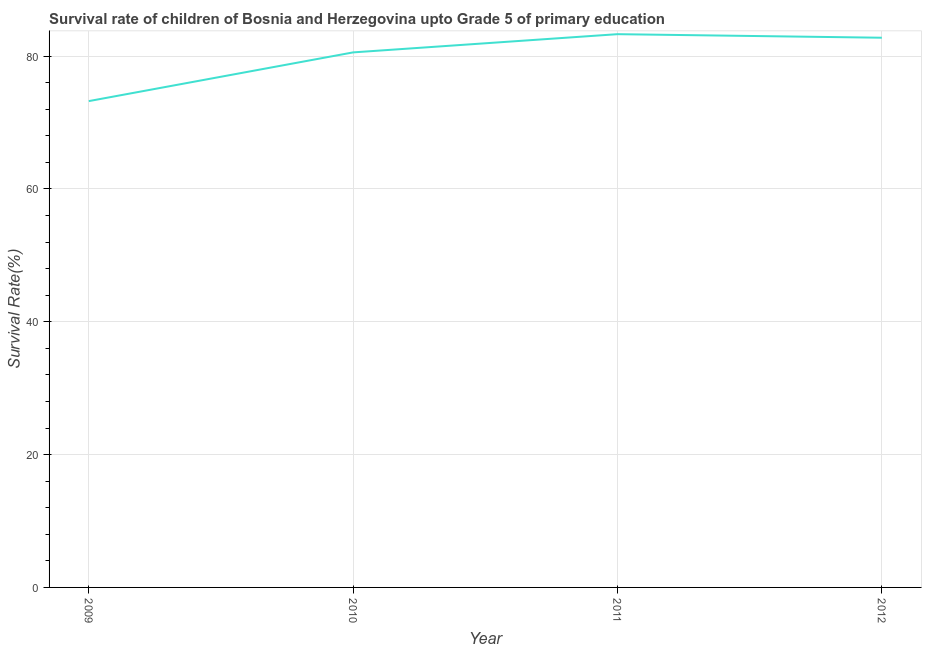What is the survival rate in 2010?
Your response must be concise. 80.56. Across all years, what is the maximum survival rate?
Provide a short and direct response. 83.31. Across all years, what is the minimum survival rate?
Offer a very short reply. 73.23. In which year was the survival rate maximum?
Your response must be concise. 2011. What is the sum of the survival rate?
Your answer should be compact. 319.87. What is the difference between the survival rate in 2011 and 2012?
Your answer should be compact. 0.54. What is the average survival rate per year?
Your answer should be compact. 79.97. What is the median survival rate?
Your response must be concise. 81.67. Do a majority of the years between 2010 and 2012 (inclusive) have survival rate greater than 8 %?
Make the answer very short. Yes. What is the ratio of the survival rate in 2009 to that in 2012?
Your answer should be compact. 0.88. Is the survival rate in 2010 less than that in 2012?
Your answer should be very brief. Yes. Is the difference between the survival rate in 2009 and 2010 greater than the difference between any two years?
Your answer should be compact. No. What is the difference between the highest and the second highest survival rate?
Provide a short and direct response. 0.54. What is the difference between the highest and the lowest survival rate?
Keep it short and to the point. 10.08. In how many years, is the survival rate greater than the average survival rate taken over all years?
Your answer should be compact. 3. How many lines are there?
Provide a short and direct response. 1. How many years are there in the graph?
Offer a very short reply. 4. What is the difference between two consecutive major ticks on the Y-axis?
Your response must be concise. 20. Are the values on the major ticks of Y-axis written in scientific E-notation?
Offer a very short reply. No. Does the graph contain any zero values?
Offer a terse response. No. What is the title of the graph?
Offer a terse response. Survival rate of children of Bosnia and Herzegovina upto Grade 5 of primary education. What is the label or title of the Y-axis?
Keep it short and to the point. Survival Rate(%). What is the Survival Rate(%) of 2009?
Provide a short and direct response. 73.23. What is the Survival Rate(%) of 2010?
Ensure brevity in your answer.  80.56. What is the Survival Rate(%) of 2011?
Give a very brief answer. 83.31. What is the Survival Rate(%) of 2012?
Keep it short and to the point. 82.77. What is the difference between the Survival Rate(%) in 2009 and 2010?
Give a very brief answer. -7.34. What is the difference between the Survival Rate(%) in 2009 and 2011?
Offer a very short reply. -10.08. What is the difference between the Survival Rate(%) in 2009 and 2012?
Provide a succinct answer. -9.54. What is the difference between the Survival Rate(%) in 2010 and 2011?
Provide a short and direct response. -2.74. What is the difference between the Survival Rate(%) in 2010 and 2012?
Your answer should be very brief. -2.21. What is the difference between the Survival Rate(%) in 2011 and 2012?
Offer a very short reply. 0.54. What is the ratio of the Survival Rate(%) in 2009 to that in 2010?
Give a very brief answer. 0.91. What is the ratio of the Survival Rate(%) in 2009 to that in 2011?
Offer a very short reply. 0.88. What is the ratio of the Survival Rate(%) in 2009 to that in 2012?
Keep it short and to the point. 0.89. What is the ratio of the Survival Rate(%) in 2010 to that in 2011?
Provide a short and direct response. 0.97. What is the ratio of the Survival Rate(%) in 2010 to that in 2012?
Provide a succinct answer. 0.97. 